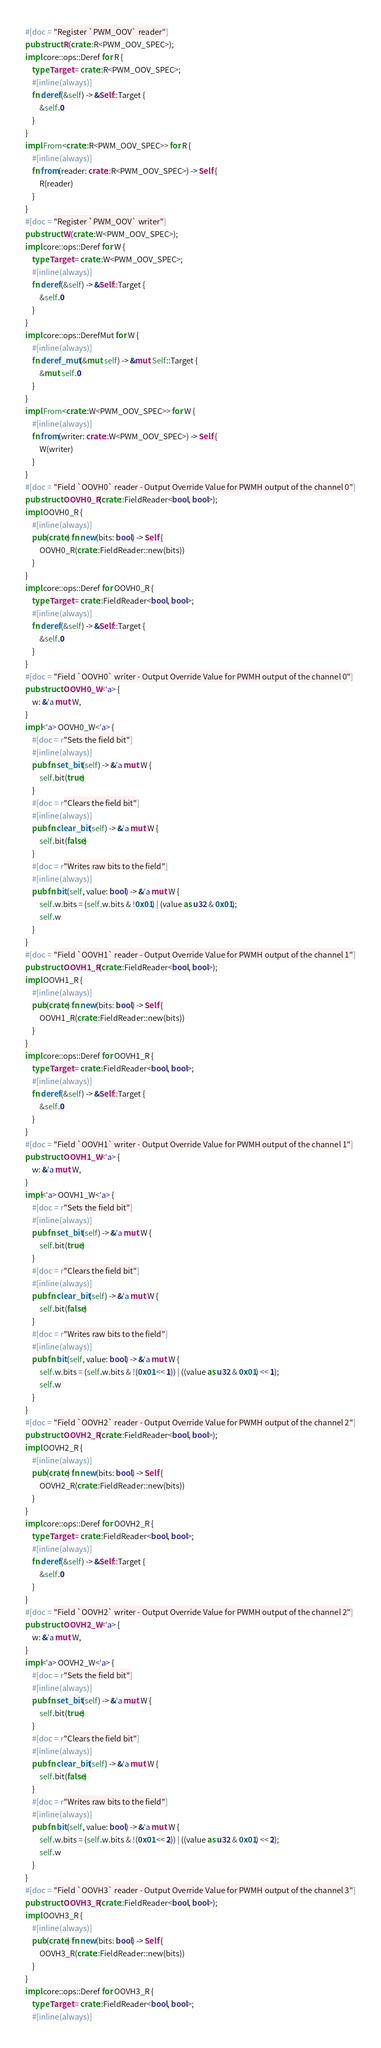Convert code to text. <code><loc_0><loc_0><loc_500><loc_500><_Rust_>#[doc = "Register `PWM_OOV` reader"]
pub struct R(crate::R<PWM_OOV_SPEC>);
impl core::ops::Deref for R {
    type Target = crate::R<PWM_OOV_SPEC>;
    #[inline(always)]
    fn deref(&self) -> &Self::Target {
        &self.0
    }
}
impl From<crate::R<PWM_OOV_SPEC>> for R {
    #[inline(always)]
    fn from(reader: crate::R<PWM_OOV_SPEC>) -> Self {
        R(reader)
    }
}
#[doc = "Register `PWM_OOV` writer"]
pub struct W(crate::W<PWM_OOV_SPEC>);
impl core::ops::Deref for W {
    type Target = crate::W<PWM_OOV_SPEC>;
    #[inline(always)]
    fn deref(&self) -> &Self::Target {
        &self.0
    }
}
impl core::ops::DerefMut for W {
    #[inline(always)]
    fn deref_mut(&mut self) -> &mut Self::Target {
        &mut self.0
    }
}
impl From<crate::W<PWM_OOV_SPEC>> for W {
    #[inline(always)]
    fn from(writer: crate::W<PWM_OOV_SPEC>) -> Self {
        W(writer)
    }
}
#[doc = "Field `OOVH0` reader - Output Override Value for PWMH output of the channel 0"]
pub struct OOVH0_R(crate::FieldReader<bool, bool>);
impl OOVH0_R {
    #[inline(always)]
    pub(crate) fn new(bits: bool) -> Self {
        OOVH0_R(crate::FieldReader::new(bits))
    }
}
impl core::ops::Deref for OOVH0_R {
    type Target = crate::FieldReader<bool, bool>;
    #[inline(always)]
    fn deref(&self) -> &Self::Target {
        &self.0
    }
}
#[doc = "Field `OOVH0` writer - Output Override Value for PWMH output of the channel 0"]
pub struct OOVH0_W<'a> {
    w: &'a mut W,
}
impl<'a> OOVH0_W<'a> {
    #[doc = r"Sets the field bit"]
    #[inline(always)]
    pub fn set_bit(self) -> &'a mut W {
        self.bit(true)
    }
    #[doc = r"Clears the field bit"]
    #[inline(always)]
    pub fn clear_bit(self) -> &'a mut W {
        self.bit(false)
    }
    #[doc = r"Writes raw bits to the field"]
    #[inline(always)]
    pub fn bit(self, value: bool) -> &'a mut W {
        self.w.bits = (self.w.bits & !0x01) | (value as u32 & 0x01);
        self.w
    }
}
#[doc = "Field `OOVH1` reader - Output Override Value for PWMH output of the channel 1"]
pub struct OOVH1_R(crate::FieldReader<bool, bool>);
impl OOVH1_R {
    #[inline(always)]
    pub(crate) fn new(bits: bool) -> Self {
        OOVH1_R(crate::FieldReader::new(bits))
    }
}
impl core::ops::Deref for OOVH1_R {
    type Target = crate::FieldReader<bool, bool>;
    #[inline(always)]
    fn deref(&self) -> &Self::Target {
        &self.0
    }
}
#[doc = "Field `OOVH1` writer - Output Override Value for PWMH output of the channel 1"]
pub struct OOVH1_W<'a> {
    w: &'a mut W,
}
impl<'a> OOVH1_W<'a> {
    #[doc = r"Sets the field bit"]
    #[inline(always)]
    pub fn set_bit(self) -> &'a mut W {
        self.bit(true)
    }
    #[doc = r"Clears the field bit"]
    #[inline(always)]
    pub fn clear_bit(self) -> &'a mut W {
        self.bit(false)
    }
    #[doc = r"Writes raw bits to the field"]
    #[inline(always)]
    pub fn bit(self, value: bool) -> &'a mut W {
        self.w.bits = (self.w.bits & !(0x01 << 1)) | ((value as u32 & 0x01) << 1);
        self.w
    }
}
#[doc = "Field `OOVH2` reader - Output Override Value for PWMH output of the channel 2"]
pub struct OOVH2_R(crate::FieldReader<bool, bool>);
impl OOVH2_R {
    #[inline(always)]
    pub(crate) fn new(bits: bool) -> Self {
        OOVH2_R(crate::FieldReader::new(bits))
    }
}
impl core::ops::Deref for OOVH2_R {
    type Target = crate::FieldReader<bool, bool>;
    #[inline(always)]
    fn deref(&self) -> &Self::Target {
        &self.0
    }
}
#[doc = "Field `OOVH2` writer - Output Override Value for PWMH output of the channel 2"]
pub struct OOVH2_W<'a> {
    w: &'a mut W,
}
impl<'a> OOVH2_W<'a> {
    #[doc = r"Sets the field bit"]
    #[inline(always)]
    pub fn set_bit(self) -> &'a mut W {
        self.bit(true)
    }
    #[doc = r"Clears the field bit"]
    #[inline(always)]
    pub fn clear_bit(self) -> &'a mut W {
        self.bit(false)
    }
    #[doc = r"Writes raw bits to the field"]
    #[inline(always)]
    pub fn bit(self, value: bool) -> &'a mut W {
        self.w.bits = (self.w.bits & !(0x01 << 2)) | ((value as u32 & 0x01) << 2);
        self.w
    }
}
#[doc = "Field `OOVH3` reader - Output Override Value for PWMH output of the channel 3"]
pub struct OOVH3_R(crate::FieldReader<bool, bool>);
impl OOVH3_R {
    #[inline(always)]
    pub(crate) fn new(bits: bool) -> Self {
        OOVH3_R(crate::FieldReader::new(bits))
    }
}
impl core::ops::Deref for OOVH3_R {
    type Target = crate::FieldReader<bool, bool>;
    #[inline(always)]</code> 